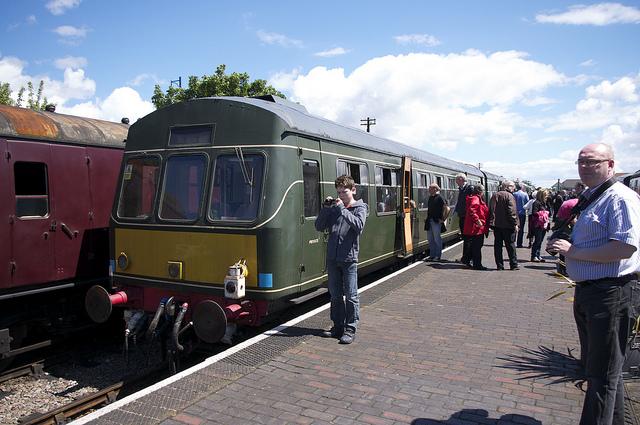What is the boy doing?
Give a very brief answer. Taking picture. Is there a balding man?
Write a very short answer. Yes. Is the train green?
Be succinct. Yes. What are the people waiting to do?
Concise answer only. Board train. Is the man getting on the train?
Write a very short answer. Yes. 